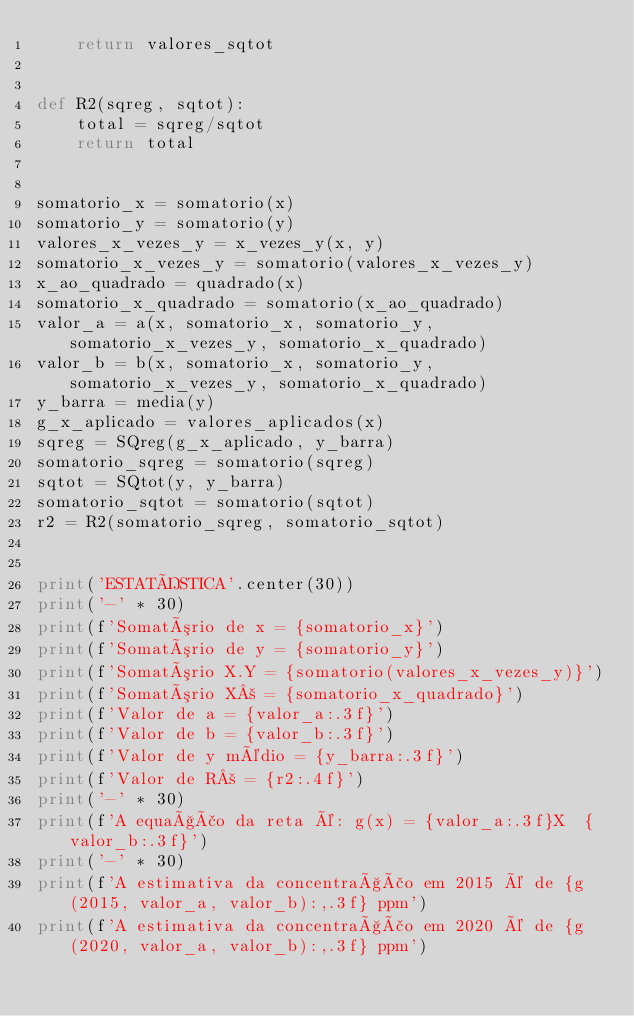<code> <loc_0><loc_0><loc_500><loc_500><_Python_>    return valores_sqtot


def R2(sqreg, sqtot):
    total = sqreg/sqtot
    return total


somatorio_x = somatorio(x)
somatorio_y = somatorio(y)
valores_x_vezes_y = x_vezes_y(x, y)
somatorio_x_vezes_y = somatorio(valores_x_vezes_y)
x_ao_quadrado = quadrado(x)
somatorio_x_quadrado = somatorio(x_ao_quadrado)
valor_a = a(x, somatorio_x, somatorio_y, somatorio_x_vezes_y, somatorio_x_quadrado)
valor_b = b(x, somatorio_x, somatorio_y, somatorio_x_vezes_y, somatorio_x_quadrado)
y_barra = media(y)
g_x_aplicado = valores_aplicados(x)
sqreg = SQreg(g_x_aplicado, y_barra)
somatorio_sqreg = somatorio(sqreg)
sqtot = SQtot(y, y_barra)
somatorio_sqtot = somatorio(sqtot)
r2 = R2(somatorio_sqreg, somatorio_sqtot)


print('ESTATÍSTICA'.center(30))
print('-' * 30)
print(f'Somatório de x = {somatorio_x}')
print(f'Somatório de y = {somatorio_y}')
print(f'Somatório X.Y = {somatorio(valores_x_vezes_y)}')
print(f'Somatório X² = {somatorio_x_quadrado}')
print(f'Valor de a = {valor_a:.3f}')
print(f'Valor de b = {valor_b:.3f}')
print(f'Valor de y médio = {y_barra:.3f}')
print(f'Valor de R² = {r2:.4f}')
print('-' * 30)
print(f'A equação da reta é: g(x) = {valor_a:.3f}X  {valor_b:.3f}')
print('-' * 30)
print(f'A estimativa da concentração em 2015 é de {g(2015, valor_a, valor_b):,.3f} ppm')
print(f'A estimativa da concentração em 2020 é de {g(2020, valor_a, valor_b):,.3f} ppm')
</code> 